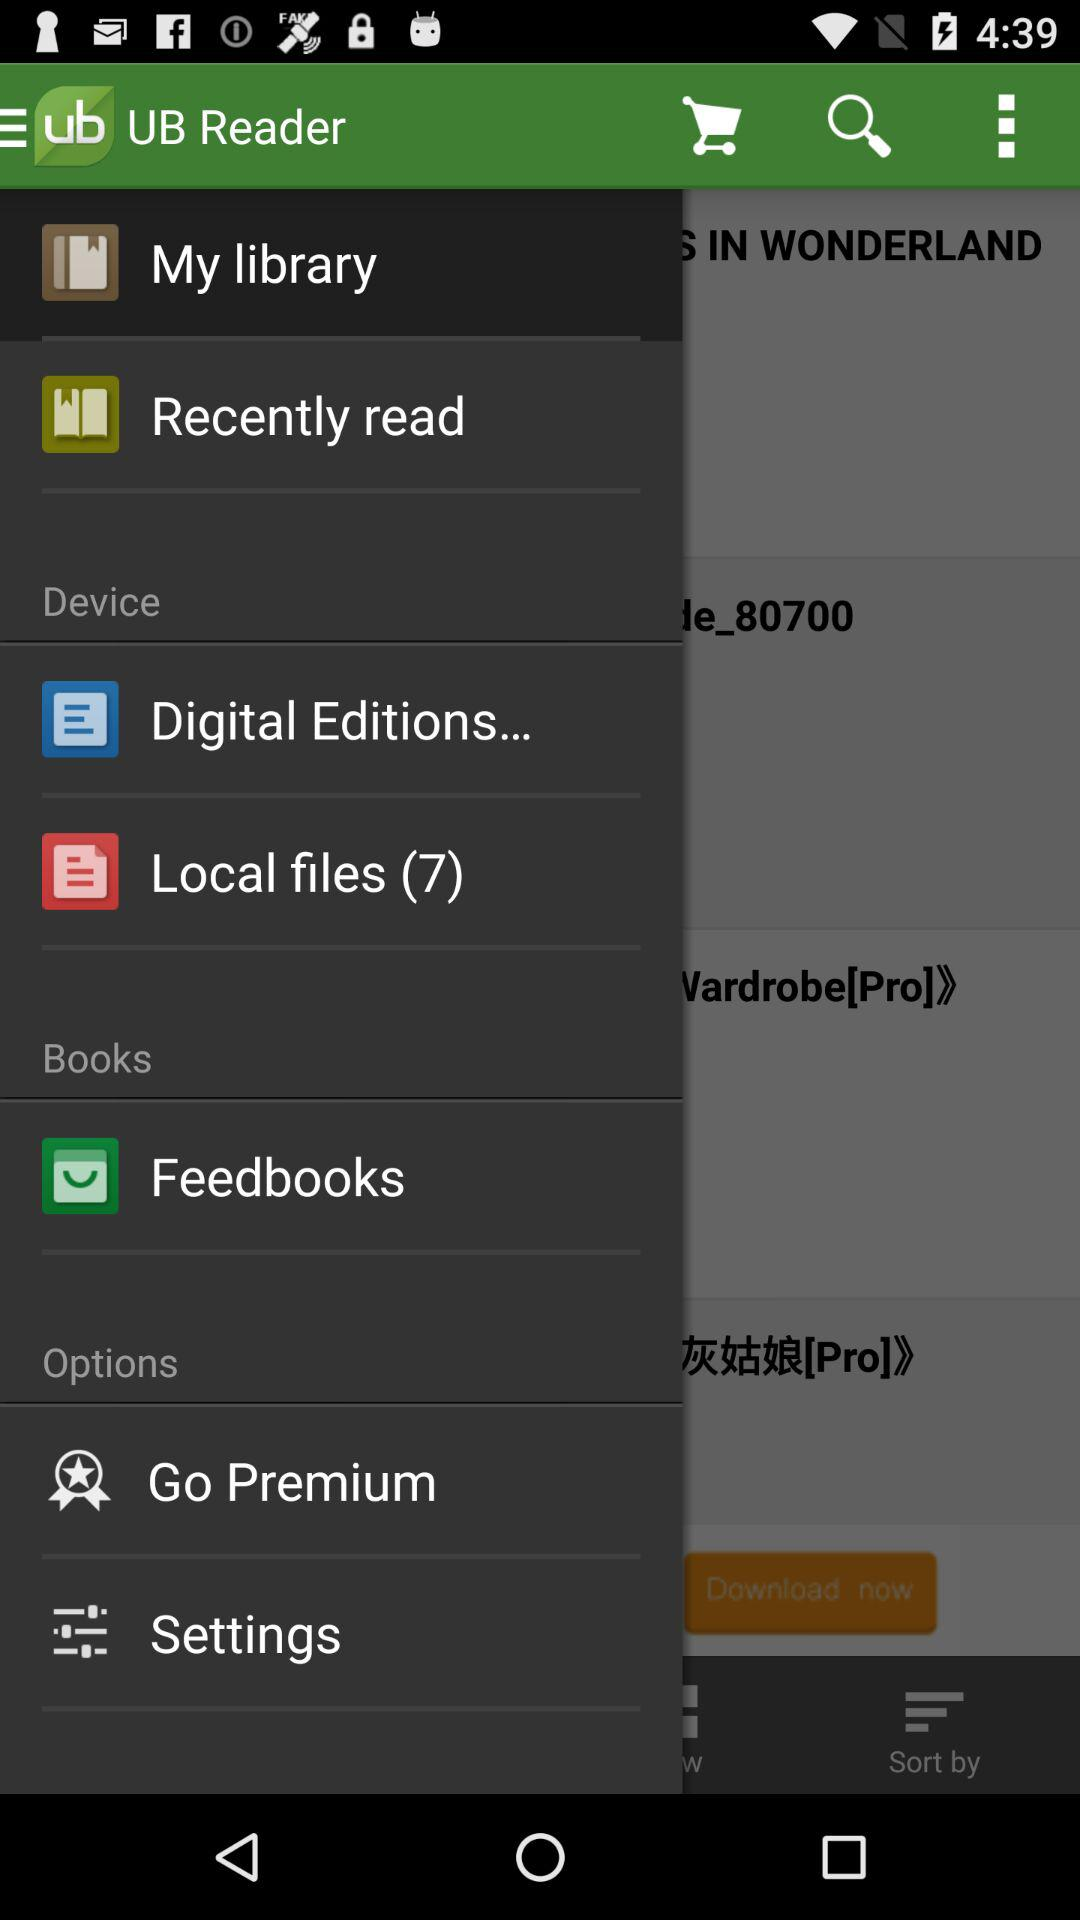What is the total number of local files? The total number of local files is 7. 